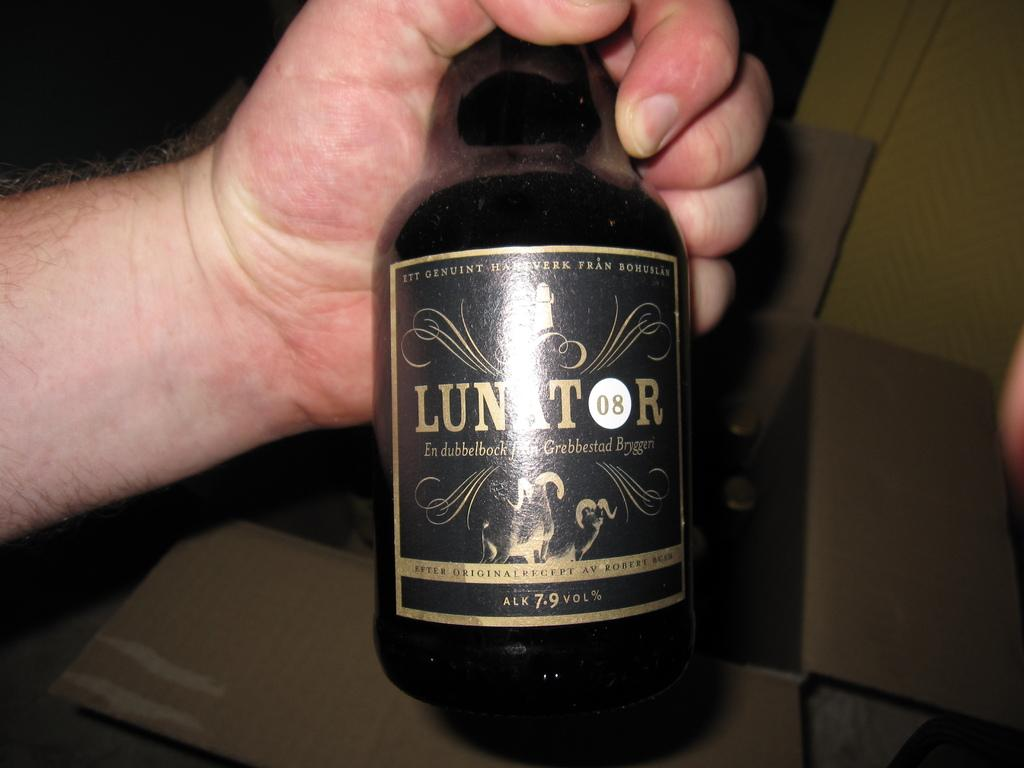Provide a one-sentence caption for the provided image. A hand holds a bottle of Lunator in front of a box. 